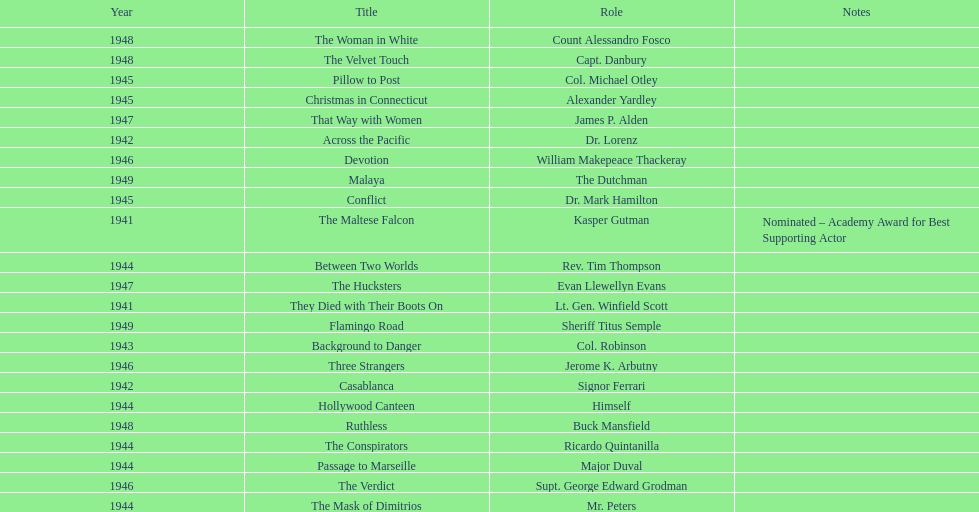How many movies has he been from 1941-1949. 23. 